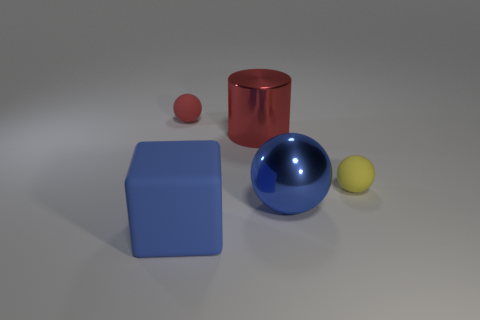Is there anything else that is made of the same material as the small red ball?
Your response must be concise. Yes. The other object that is made of the same material as the large red object is what size?
Offer a terse response. Large. What is the color of the tiny sphere in front of the object behind the large red thing?
Give a very brief answer. Yellow. Is the shape of the large red metal thing the same as the thing behind the red metal cylinder?
Your answer should be compact. No. How many blue matte blocks have the same size as the blue metal sphere?
Your response must be concise. 1. What is the material of the yellow object that is the same shape as the tiny red matte object?
Provide a succinct answer. Rubber. Is the color of the sphere on the right side of the big blue metal thing the same as the sphere that is behind the tiny yellow rubber object?
Your answer should be compact. No. What is the shape of the tiny matte thing on the left side of the big blue metallic thing?
Make the answer very short. Sphere. What color is the large matte thing?
Your answer should be compact. Blue. There is a large object that is the same material as the cylinder; what shape is it?
Keep it short and to the point. Sphere. 